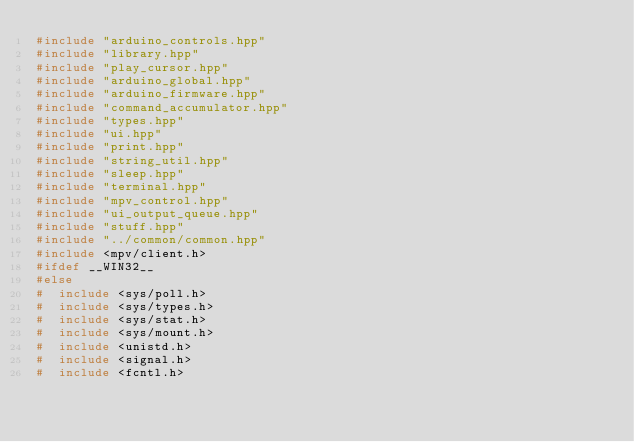<code> <loc_0><loc_0><loc_500><loc_500><_C++_>#include "arduino_controls.hpp"
#include "library.hpp"
#include "play_cursor.hpp"
#include "arduino_global.hpp"
#include "arduino_firmware.hpp"
#include "command_accumulator.hpp"
#include "types.hpp"
#include "ui.hpp"
#include "print.hpp"
#include "string_util.hpp"
#include "sleep.hpp"
#include "terminal.hpp"
#include "mpv_control.hpp"
#include "ui_output_queue.hpp"
#include "stuff.hpp"
#include "../common/common.hpp"
#include <mpv/client.h>
#ifdef __WIN32__
#else
#  include <sys/poll.h>
#  include <sys/types.h>
#  include <sys/stat.h>
#  include <sys/mount.h>
#  include <unistd.h>
#  include <signal.h>
#  include <fcntl.h></code> 